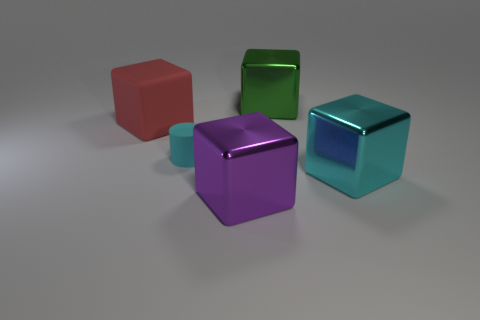Add 3 large blue things. How many objects exist? 8 Subtract all cubes. How many objects are left? 1 Add 4 large things. How many large things exist? 8 Subtract 1 cyan cubes. How many objects are left? 4 Subtract all big purple metal blocks. Subtract all big purple objects. How many objects are left? 3 Add 3 tiny cyan cylinders. How many tiny cyan cylinders are left? 4 